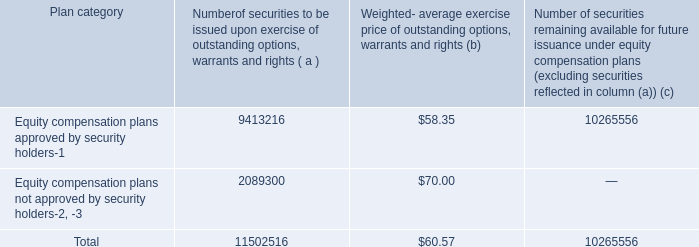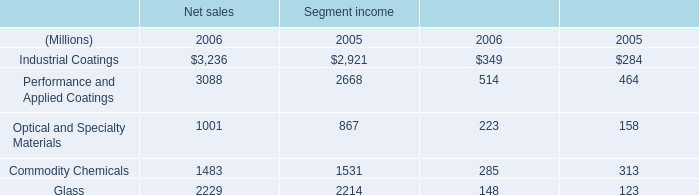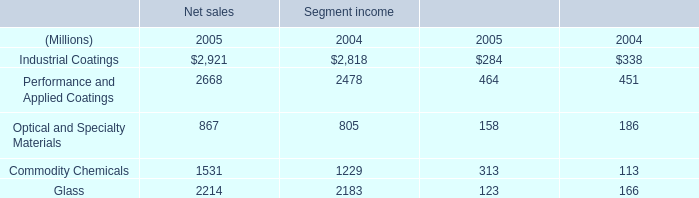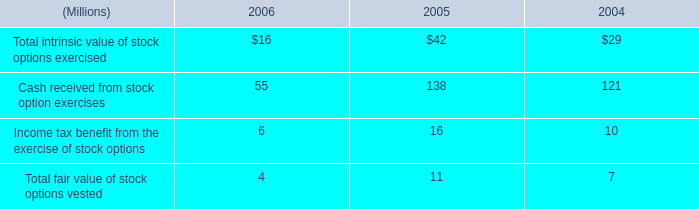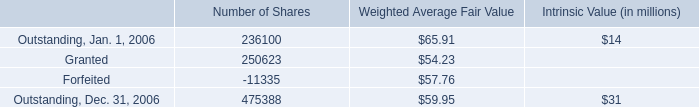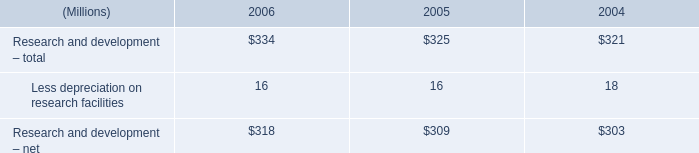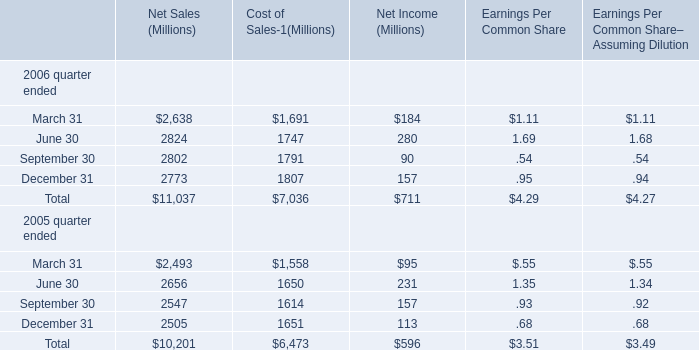What is the growing rate of Net Income in the year with the most Cost of Sales? 
Computations: ((711 - 596) / 596)
Answer: 0.19295. 